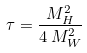<formula> <loc_0><loc_0><loc_500><loc_500>\tau = \frac { M _ { H } ^ { 2 } } { 4 \, M _ { W } ^ { 2 } }</formula> 